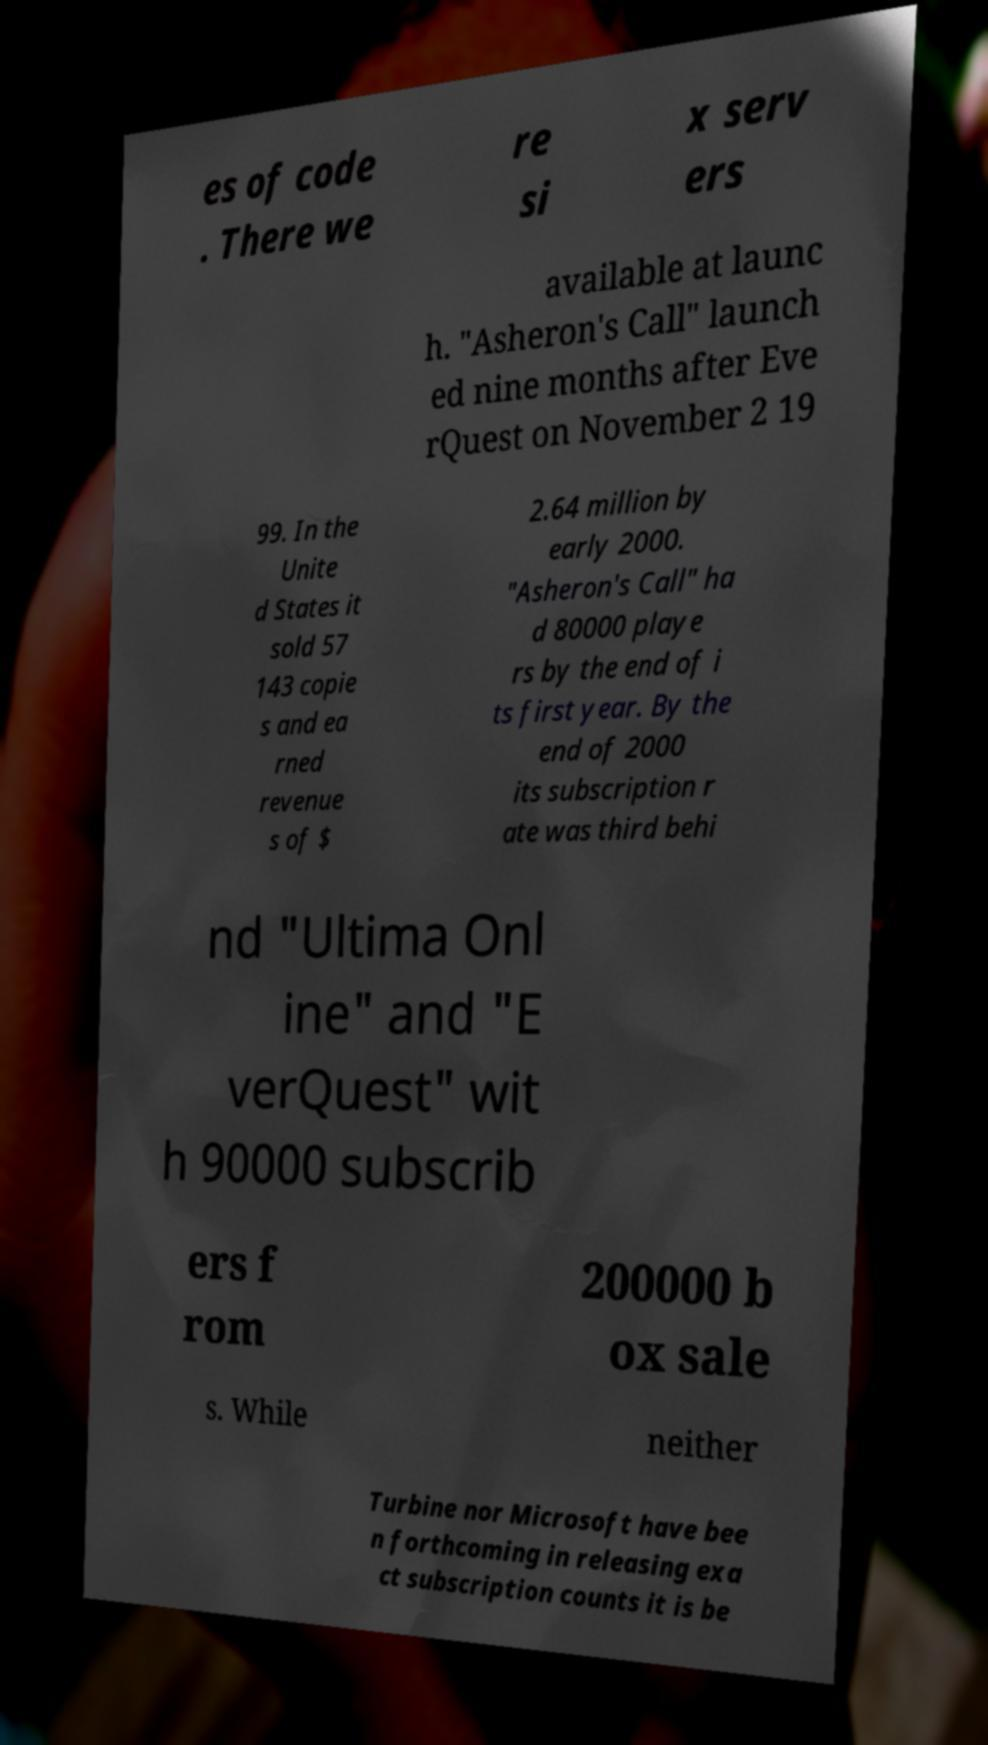Could you extract and type out the text from this image? es of code . There we re si x serv ers available at launc h. "Asheron's Call" launch ed nine months after Eve rQuest on November 2 19 99. In the Unite d States it sold 57 143 copie s and ea rned revenue s of $ 2.64 million by early 2000. "Asheron's Call" ha d 80000 playe rs by the end of i ts first year. By the end of 2000 its subscription r ate was third behi nd "Ultima Onl ine" and "E verQuest" wit h 90000 subscrib ers f rom 200000 b ox sale s. While neither Turbine nor Microsoft have bee n forthcoming in releasing exa ct subscription counts it is be 